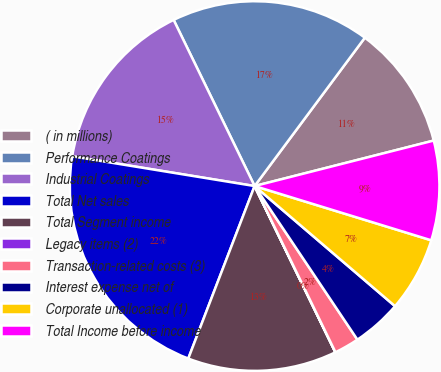<chart> <loc_0><loc_0><loc_500><loc_500><pie_chart><fcel>( in millions)<fcel>Performance Coatings<fcel>Industrial Coatings<fcel>Total Net sales<fcel>Total Segment income<fcel>Legacy items (2)<fcel>Transaction-related costs (3)<fcel>Interest expense net of<fcel>Corporate unallocated (1)<fcel>Total Income before income<nl><fcel>10.87%<fcel>17.39%<fcel>15.21%<fcel>21.73%<fcel>13.04%<fcel>0.01%<fcel>2.18%<fcel>4.35%<fcel>6.52%<fcel>8.7%<nl></chart> 